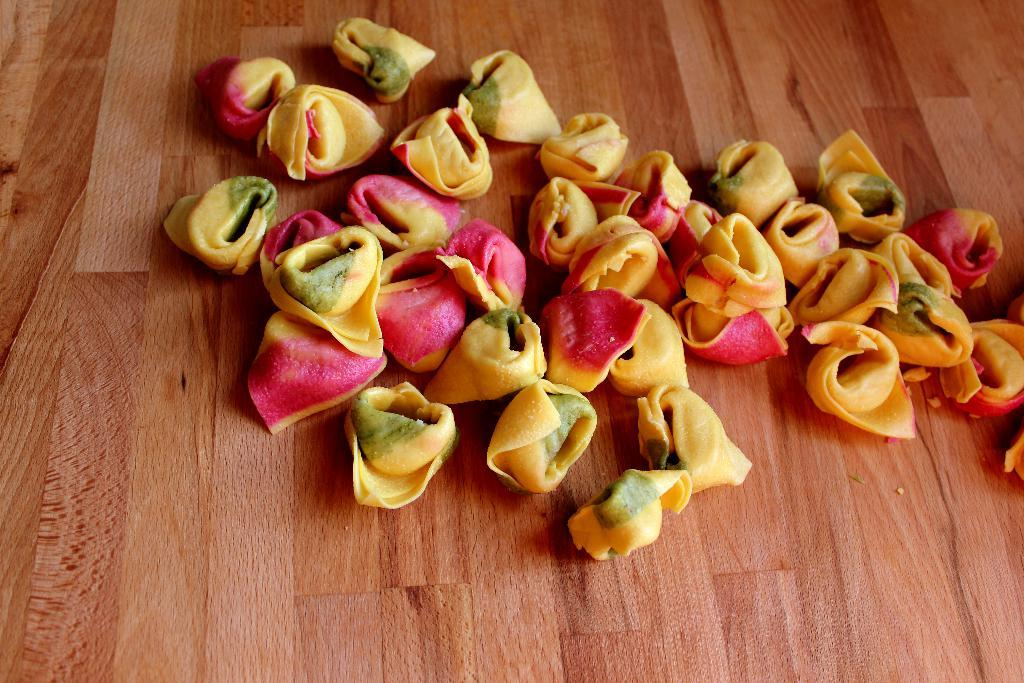What is the primary object in the image? There is food placed on a table in the image. Can you describe the setting where the food is located? The food is placed on a table, which suggests it might be in a dining area. What might someone be about to do with the food on the table? Someone might be about to eat the food. What type of shoes can be seen in the image? There are no shoes present in the image; it features food placed on a table. Can you tell me how many twigs are used as decoration in the image? There is no mention of twigs in the image; it only features food placed on a table. 